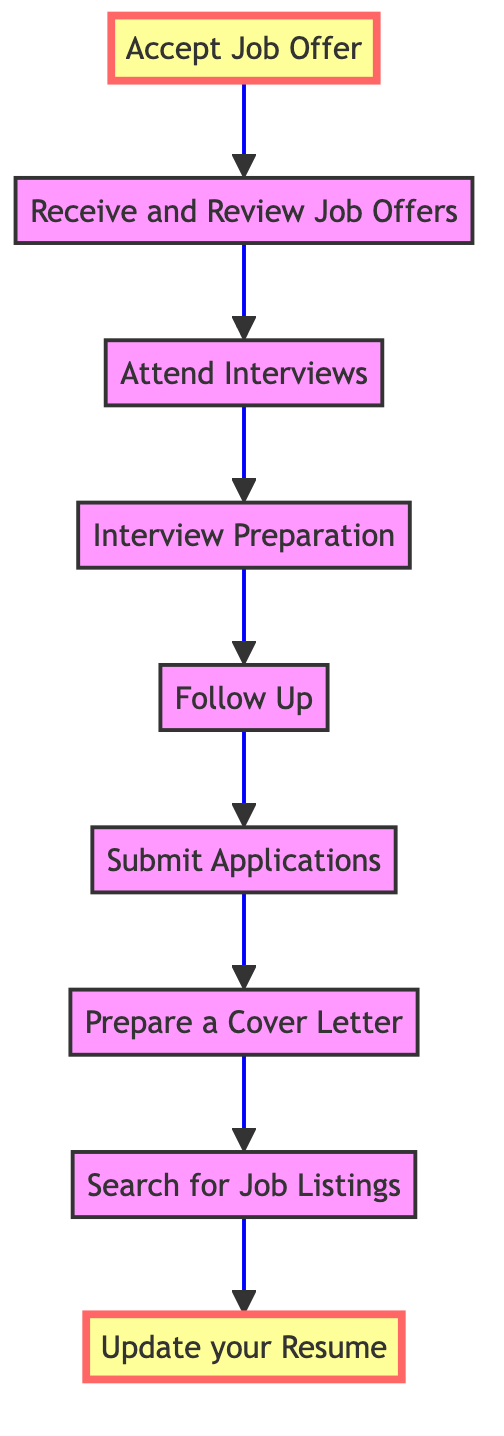What is the first step in the diagram? The first step in the diagram is found at the bottom node labeled "Update your Resume," which indicates the initial action required in the application process.
Answer: Update your Resume How many total steps are in the diagram? By counting the number of nodes in the flowchart, there are nine distinct steps listed from the first step to the last step, detailing the process of applying for a part-time job.
Answer: Nine What step directly follows "Attend Interviews"? Referring to the flow of the diagram, the step that comes directly after "Attend Interviews" is "Receive and Review Job Offers," which indicates the subsequent action after attending an interview.
Answer: Receive and Review Job Offers Which step precedes "Submit Applications"? In the flowchart, "Prepare a Cover Letter" comes before "Submit Applications," meaning it's an essential action to take prior to applying for the jobs.
Answer: Prepare a Cover Letter What is the last step of the flow chart? The last step in the flowchart is found at the top node, which is labeled "Accept Job Offer," indicating the final action one takes after receiving a job offer.
Answer: Accept Job Offer What two steps connect "Follow Up" and "Attend Interviews"? The two steps connecting "Follow Up" and "Attend Interviews" are "Submit Applications" and "Interview Preparation," showing the sequential relationship in the job application process.
Answer: Submit Applications, Interview Preparation Which step emphasizes the preparation for interviews? The node labeled "Interview Preparation" explicitly focuses on the actions necessary to prepare for potential interviews, making it clear that preparation is critical.
Answer: Interview Preparation How does the flowchart indicate the importance of following up on applications? The flowchart includes a distinct step labeled "Follow Up," which suggests that it is essential to check the status of your application if there has been no response, indicating its importance in the job search process.
Answer: Follow Up 